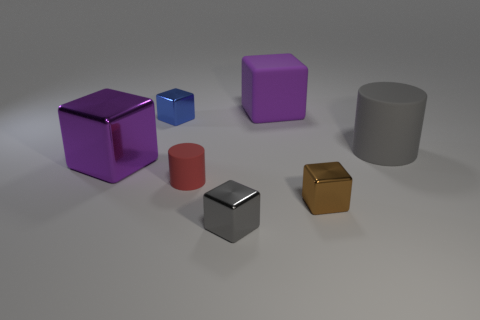Subtract all purple cubes. How many were subtracted if there are1purple cubes left? 1 Subtract all gray blocks. How many blocks are left? 4 Subtract all gray cubes. How many cubes are left? 4 Subtract all gray blocks. Subtract all yellow cylinders. How many blocks are left? 4 Add 1 gray balls. How many objects exist? 8 Subtract all cubes. How many objects are left? 2 Subtract 0 cyan cubes. How many objects are left? 7 Subtract all tiny gray objects. Subtract all gray shiny cubes. How many objects are left? 5 Add 5 gray metal blocks. How many gray metal blocks are left? 6 Add 4 large purple metallic cubes. How many large purple metallic cubes exist? 5 